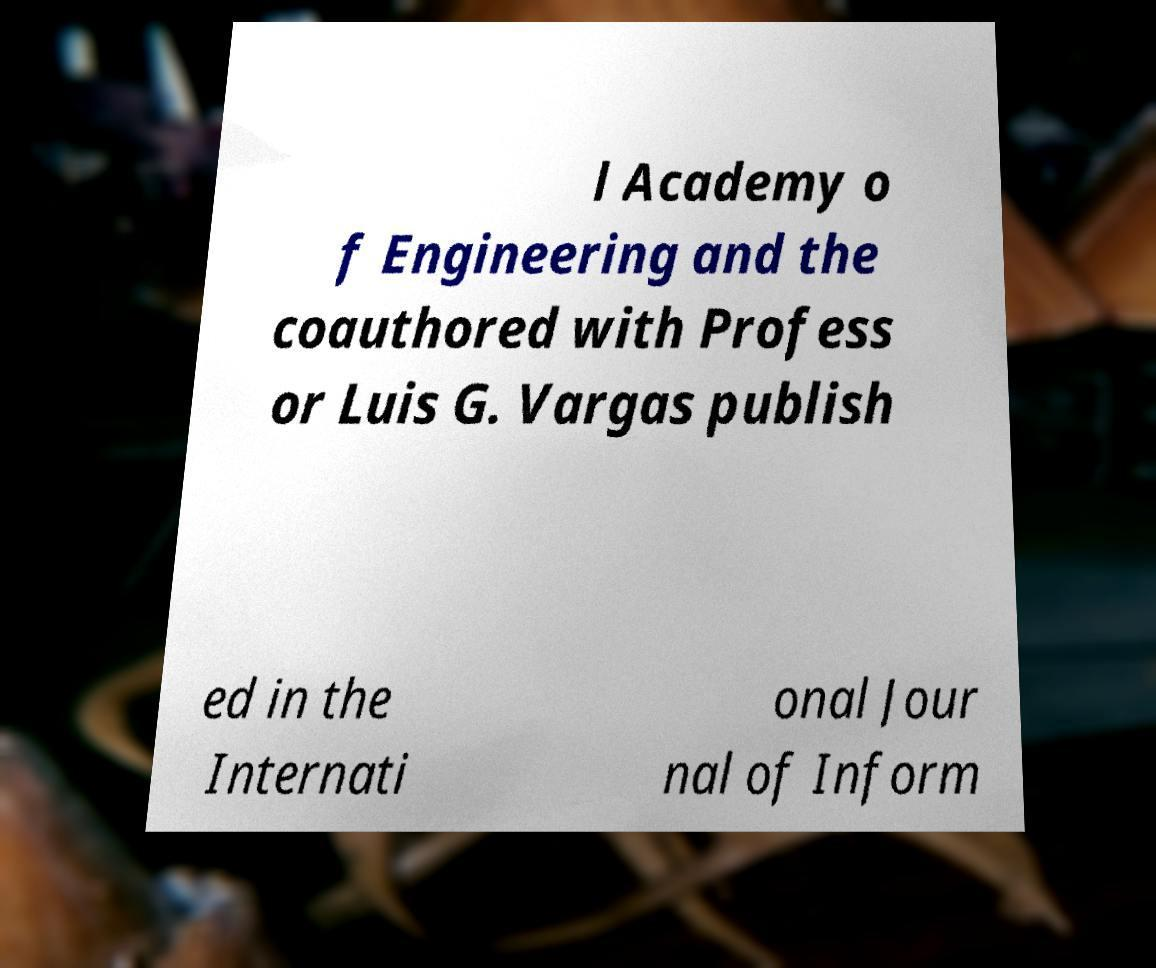Can you accurately transcribe the text from the provided image for me? l Academy o f Engineering and the coauthored with Profess or Luis G. Vargas publish ed in the Internati onal Jour nal of Inform 